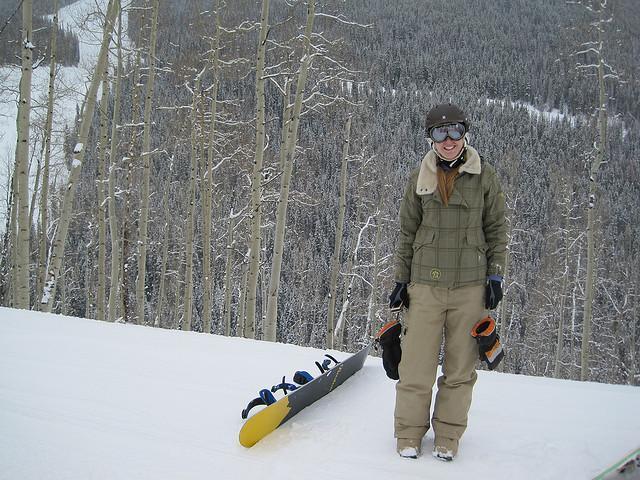How many boats can be seen?
Give a very brief answer. 0. 